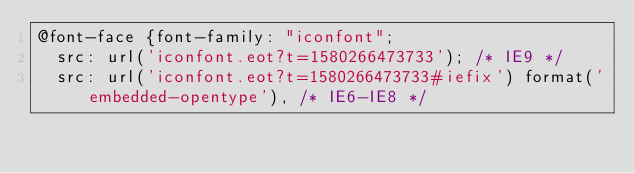Convert code to text. <code><loc_0><loc_0><loc_500><loc_500><_CSS_>@font-face {font-family: "iconfont";
  src: url('iconfont.eot?t=1580266473733'); /* IE9 */
  src: url('iconfont.eot?t=1580266473733#iefix') format('embedded-opentype'), /* IE6-IE8 */</code> 